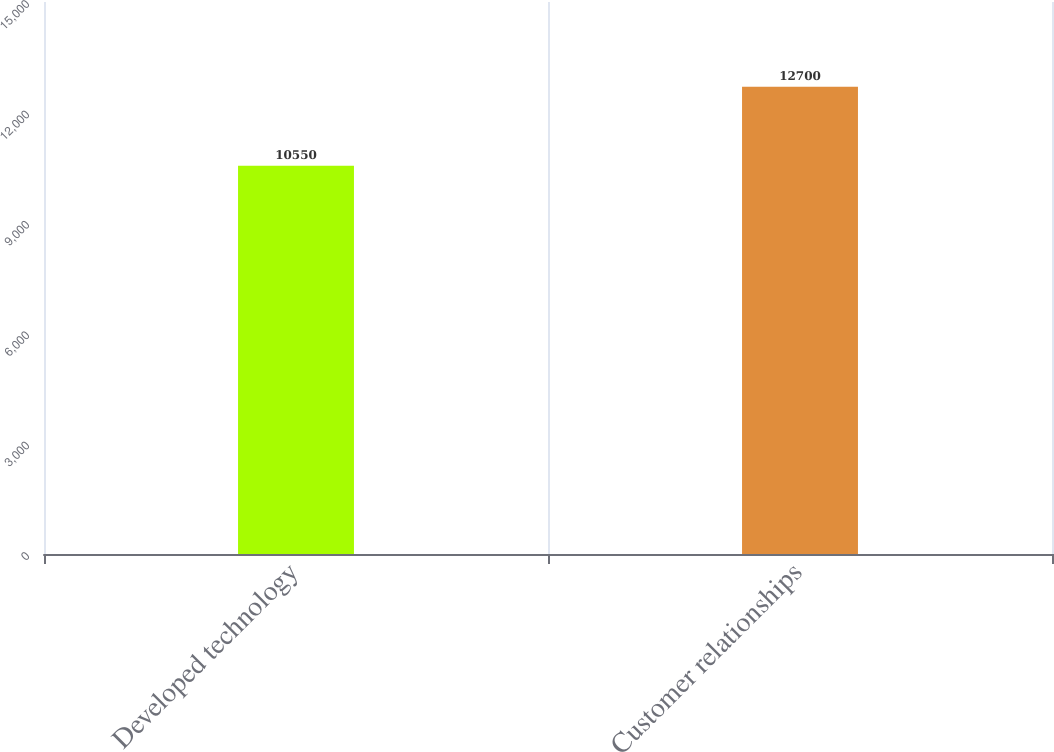Convert chart. <chart><loc_0><loc_0><loc_500><loc_500><bar_chart><fcel>Developed technology<fcel>Customer relationships<nl><fcel>10550<fcel>12700<nl></chart> 